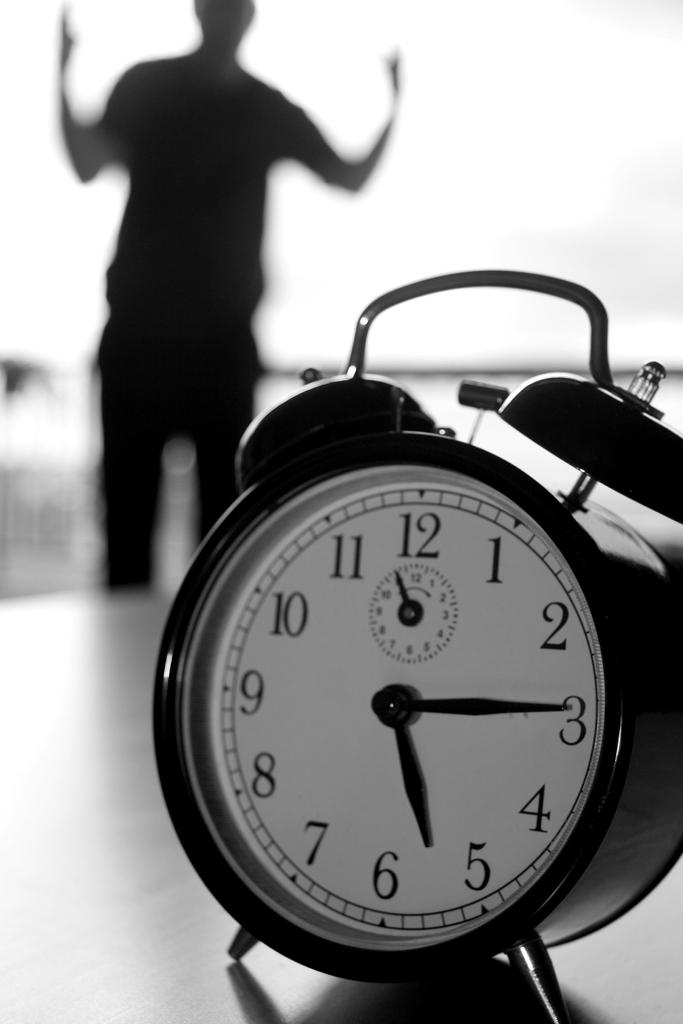Provide a one-sentence caption for the provided image. A man standing near an alarm clock that is almost a quarter past 5. 